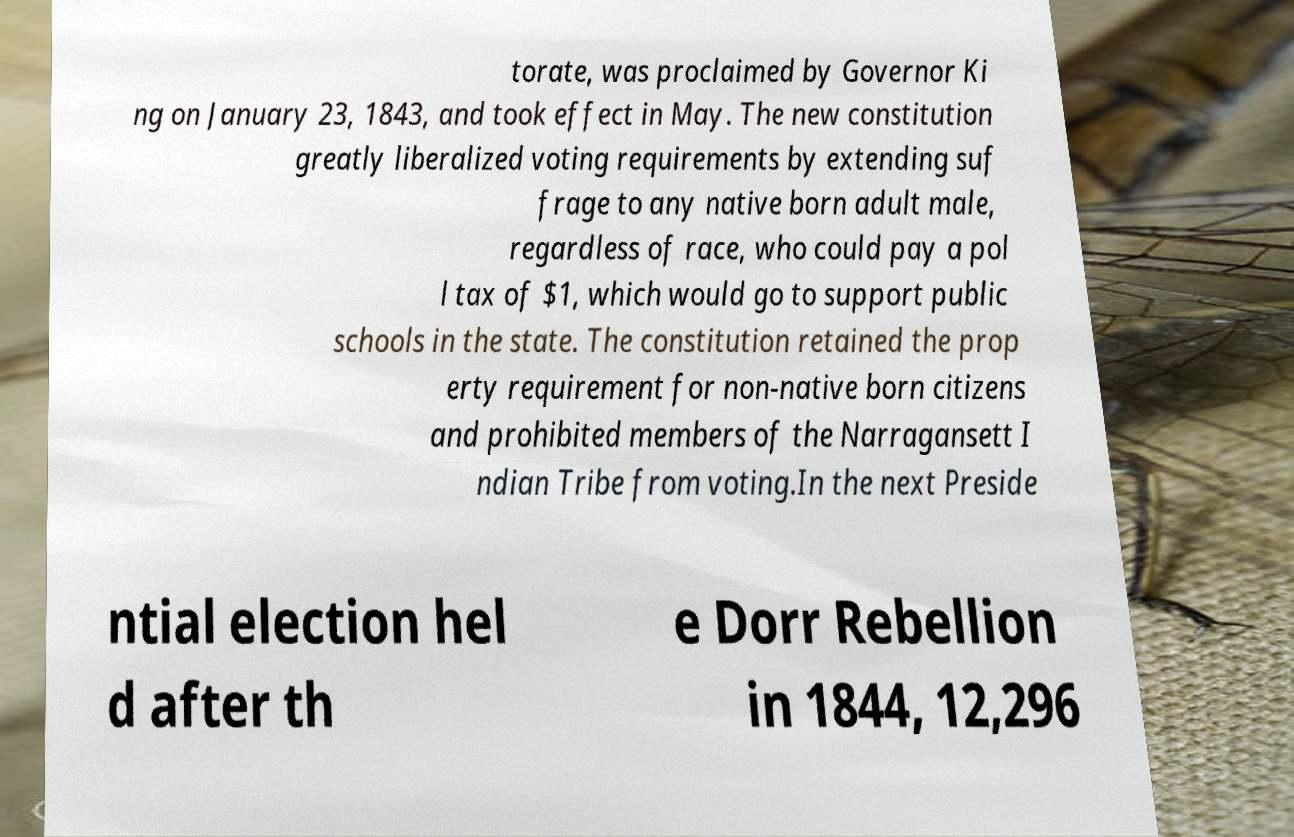Could you assist in decoding the text presented in this image and type it out clearly? torate, was proclaimed by Governor Ki ng on January 23, 1843, and took effect in May. The new constitution greatly liberalized voting requirements by extending suf frage to any native born adult male, regardless of race, who could pay a pol l tax of $1, which would go to support public schools in the state. The constitution retained the prop erty requirement for non-native born citizens and prohibited members of the Narragansett I ndian Tribe from voting.In the next Preside ntial election hel d after th e Dorr Rebellion in 1844, 12,296 